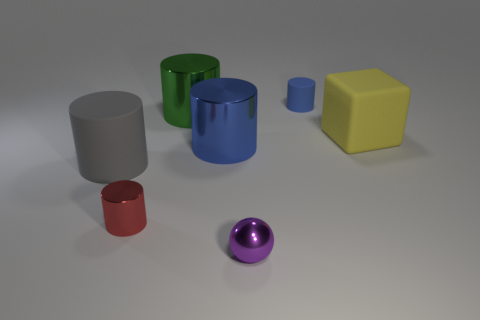Is the number of tiny metal cylinders greater than the number of small cyan balls? After closely examining the image, it appears that the number of small cylinders is equal to the number of cyan balls, which is one of each. Each object is rendered with a distinct material and shape, contributing to a varied visual composition. 